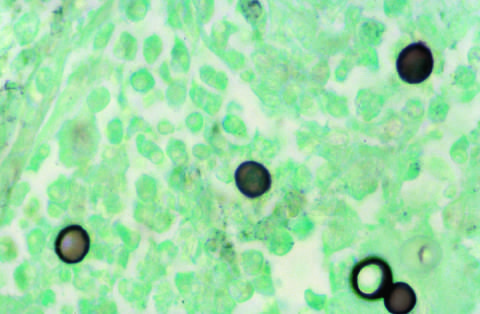what highlights the broad-based budding seen in blastomyces immitis organisms?
Answer the question using a single word or phrase. Silver stain 